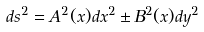<formula> <loc_0><loc_0><loc_500><loc_500>d s ^ { 2 } = A ^ { 2 } ( x ) d x ^ { 2 } \pm B ^ { 2 } ( x ) d y ^ { 2 }</formula> 